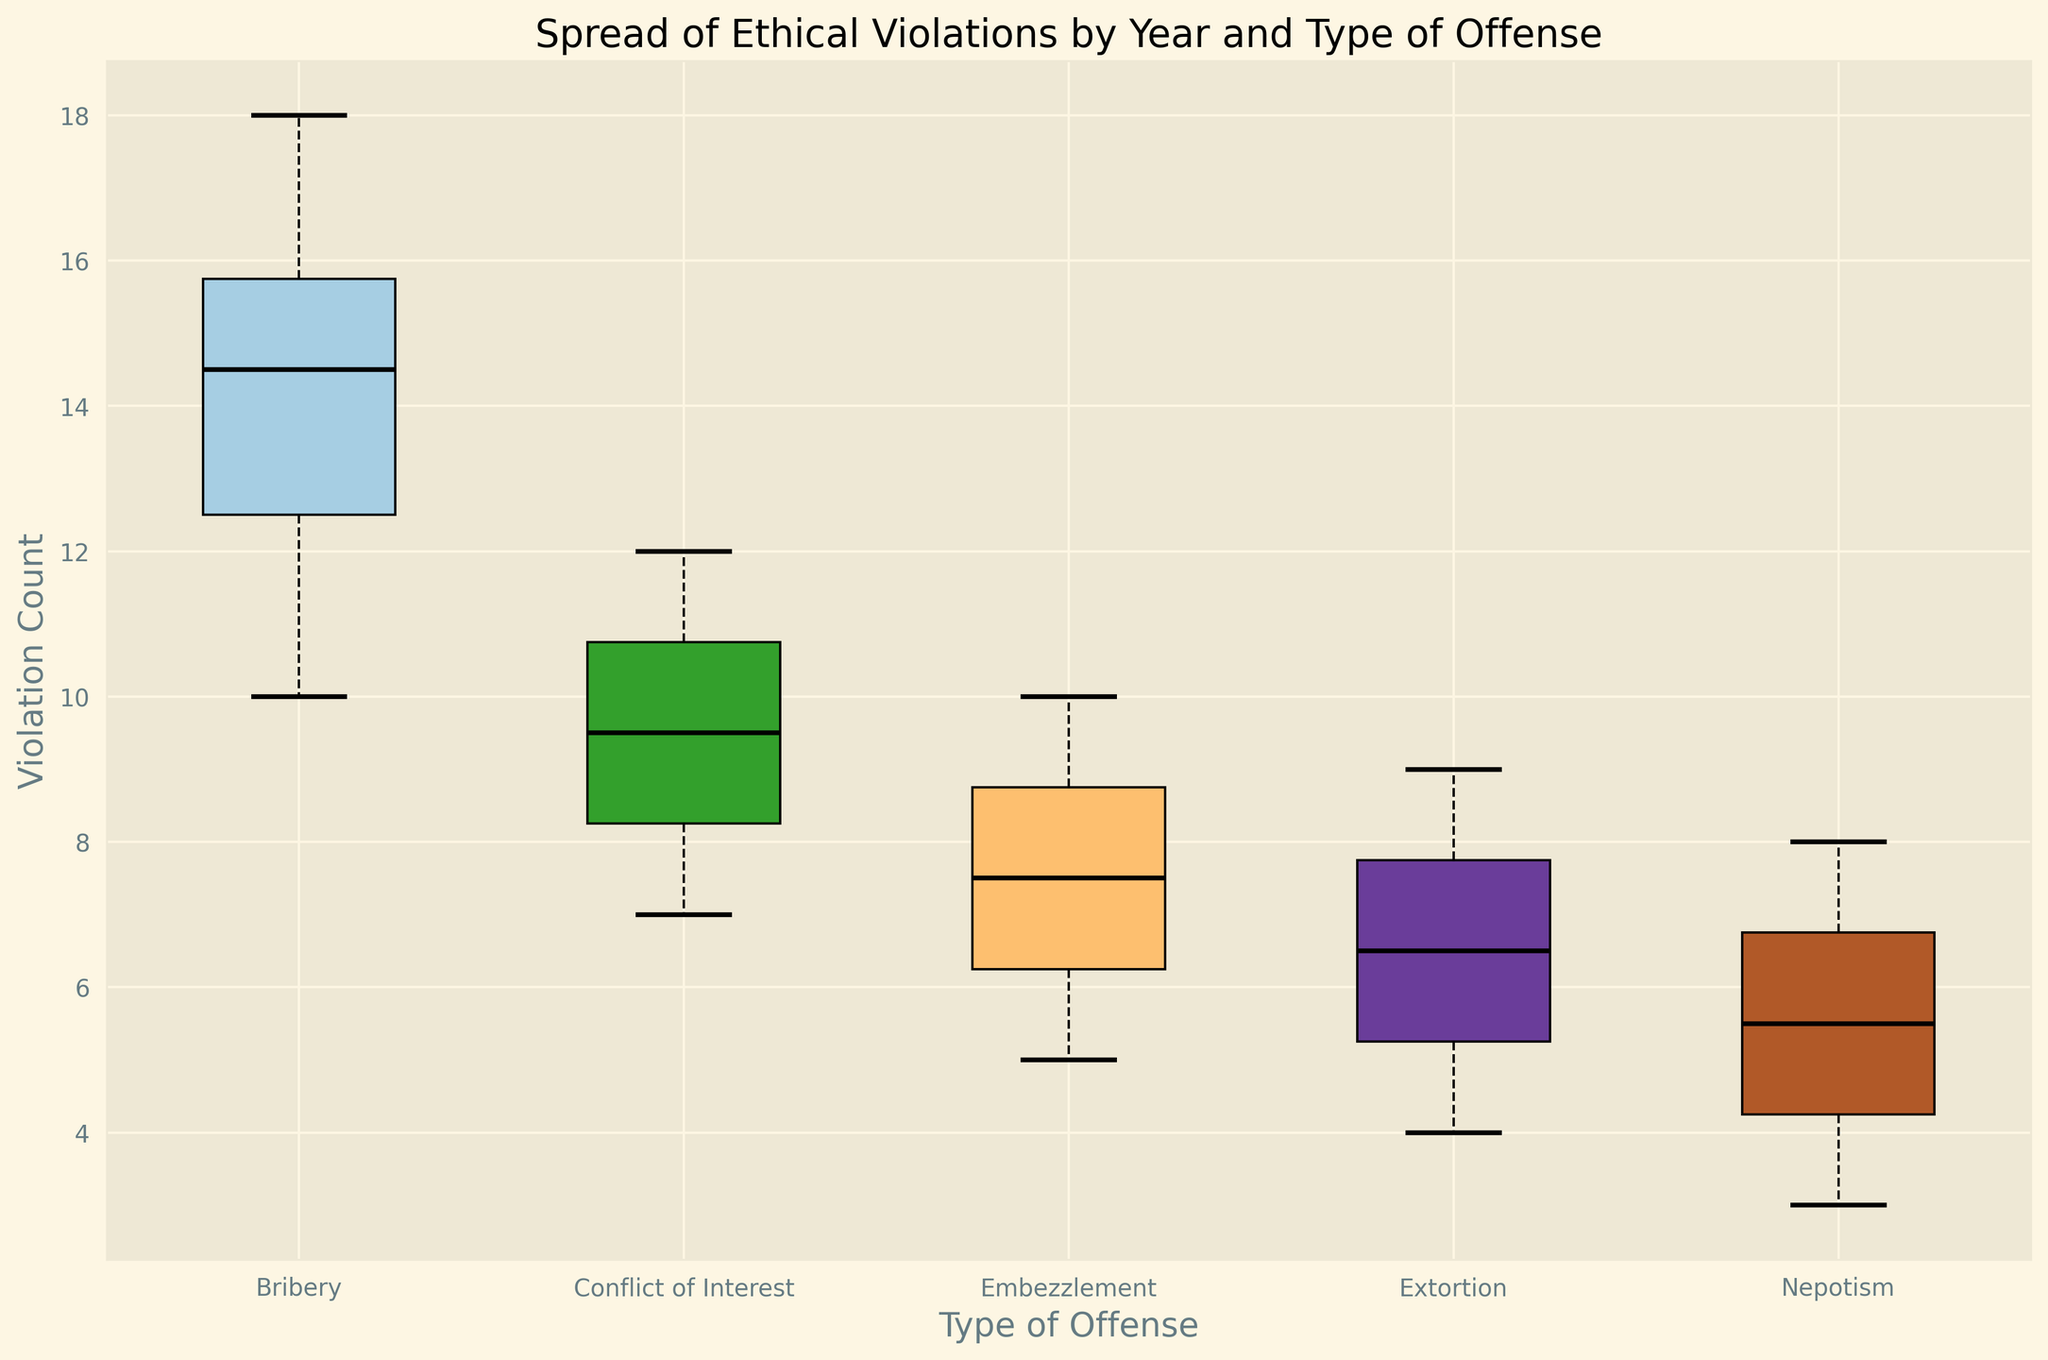What's the highest median violation count among the types of offenses? By examining the figure, find the median values, which are indicated by black lines within each box. Compare the medians of all the types of offenses. Bribery has the highest median.
Answer: Bribery Which type of offense shows the least variation in violation counts over the years? Variation is depicted by the spread of the box plot. The narrower the box, the less variation there is. Nepotism shows the narrowest box, indicating the least variation.
Answer: Nepotism Comparing Bribery and Conflict of Interest, which one has a higher maximum violation count? Look at the highest points of the whiskers for Bribery and Conflict of Interest. Bribery's whisker reaches higher than Conflict of Interest's, indicating a higher maximum violation count.
Answer: Bribery What is the difference between the highest and lowest violation counts for Embezzlement? Identify the top whisker (highest value) and the bottom whisker (lowest value) for Embezzlement. The difference is 10 (highest) - 5 (lowest) = 5.
Answer: 5 Which type of offense has the most outliers, and how many are there? Outliers are indicated by red dots. Count the red dots for each type of offense. Bribery has the most outliers, with three red dots.
Answer: Bribery, 3 If we sum the median values of all types of offenses, what is the total? Determine the median value for each type of offense and add them: Bribery (14), Embezzlement (7), Conflict of Interest (9), Nepotism (6), and Extortion (6). The sum is 14 + 7 + 9 + 6 + 6 = 42.
Answer: 42 Which type of offense has both the highest median and the highest upper quartile value? Identify the offense type with the highest median (Bribery) and check its upper quartile (top of the box). Bribery also has the highest upper quartile.
Answer: Bribery Comparing the median values, how much greater is Bribery compared to Nepotism? Find the median values for Bribery (14) and Nepotism (6). The difference is 14 - 6 = 8.
Answer: 8 Is there any type of offense where the median value equals the minimum or maximum value? Check if any type's median (black line) aligns with its whiskers' endpoints. None of the medians align exactly with the minimum or maximum values.
Answer: No 